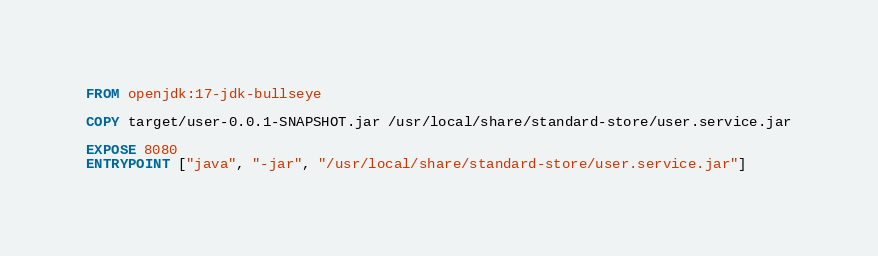<code> <loc_0><loc_0><loc_500><loc_500><_Dockerfile_>FROM openjdk:17-jdk-bullseye

COPY target/user-0.0.1-SNAPSHOT.jar /usr/local/share/standard-store/user.service.jar

EXPOSE 8080
ENTRYPOINT ["java", "-jar", "/usr/local/share/standard-store/user.service.jar"]</code> 